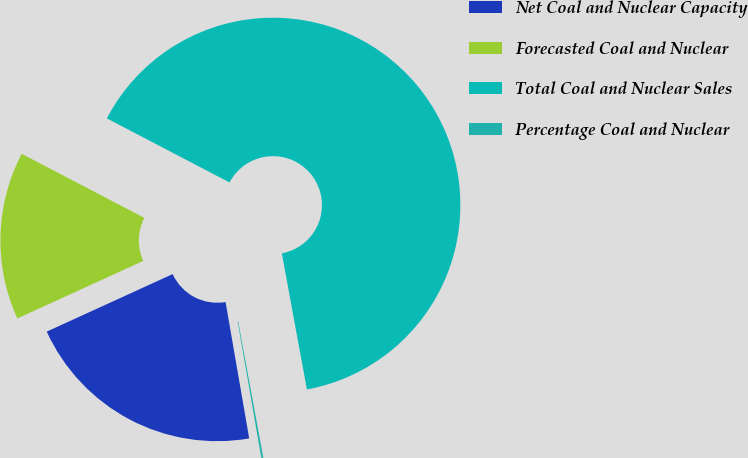Convert chart. <chart><loc_0><loc_0><loc_500><loc_500><pie_chart><fcel>Net Coal and Nuclear Capacity<fcel>Forecasted Coal and Nuclear<fcel>Total Coal and Nuclear Sales<fcel>Percentage Coal and Nuclear<nl><fcel>20.91%<fcel>14.48%<fcel>64.44%<fcel>0.17%<nl></chart> 